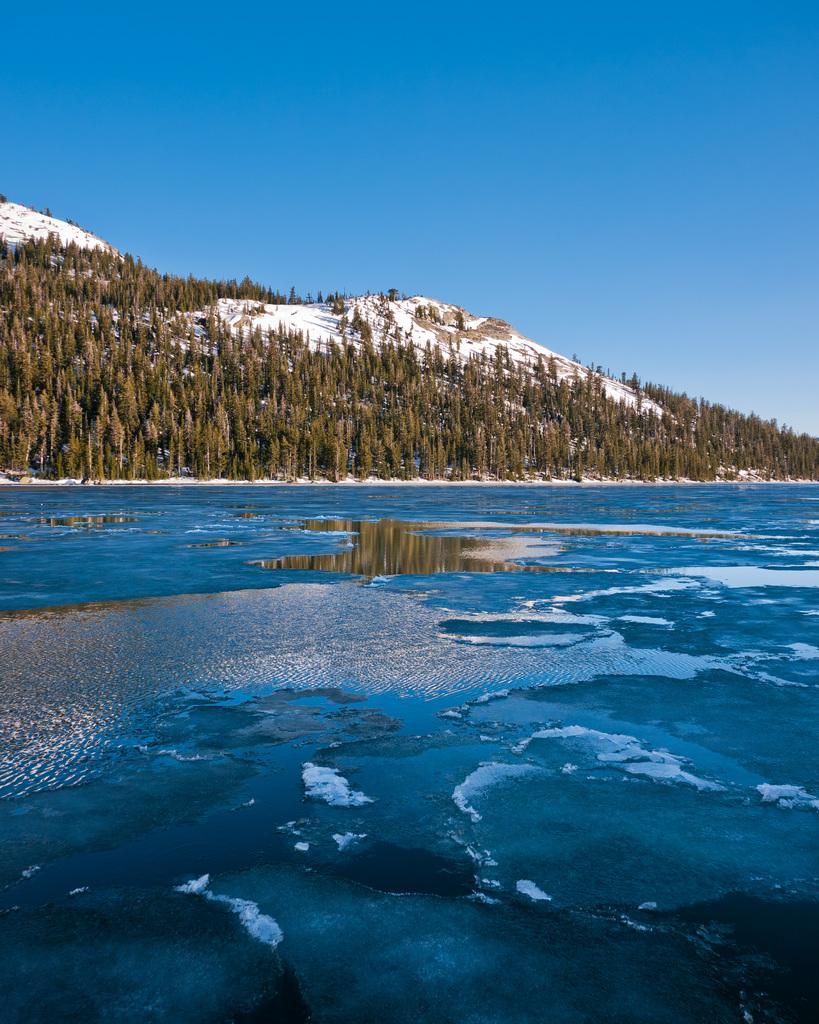Can you describe this image briefly? In this picture, we can see water, trees, mountains with snow and the sky. 